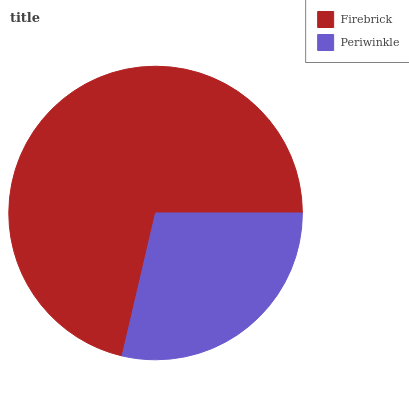Is Periwinkle the minimum?
Answer yes or no. Yes. Is Firebrick the maximum?
Answer yes or no. Yes. Is Periwinkle the maximum?
Answer yes or no. No. Is Firebrick greater than Periwinkle?
Answer yes or no. Yes. Is Periwinkle less than Firebrick?
Answer yes or no. Yes. Is Periwinkle greater than Firebrick?
Answer yes or no. No. Is Firebrick less than Periwinkle?
Answer yes or no. No. Is Firebrick the high median?
Answer yes or no. Yes. Is Periwinkle the low median?
Answer yes or no. Yes. Is Periwinkle the high median?
Answer yes or no. No. Is Firebrick the low median?
Answer yes or no. No. 